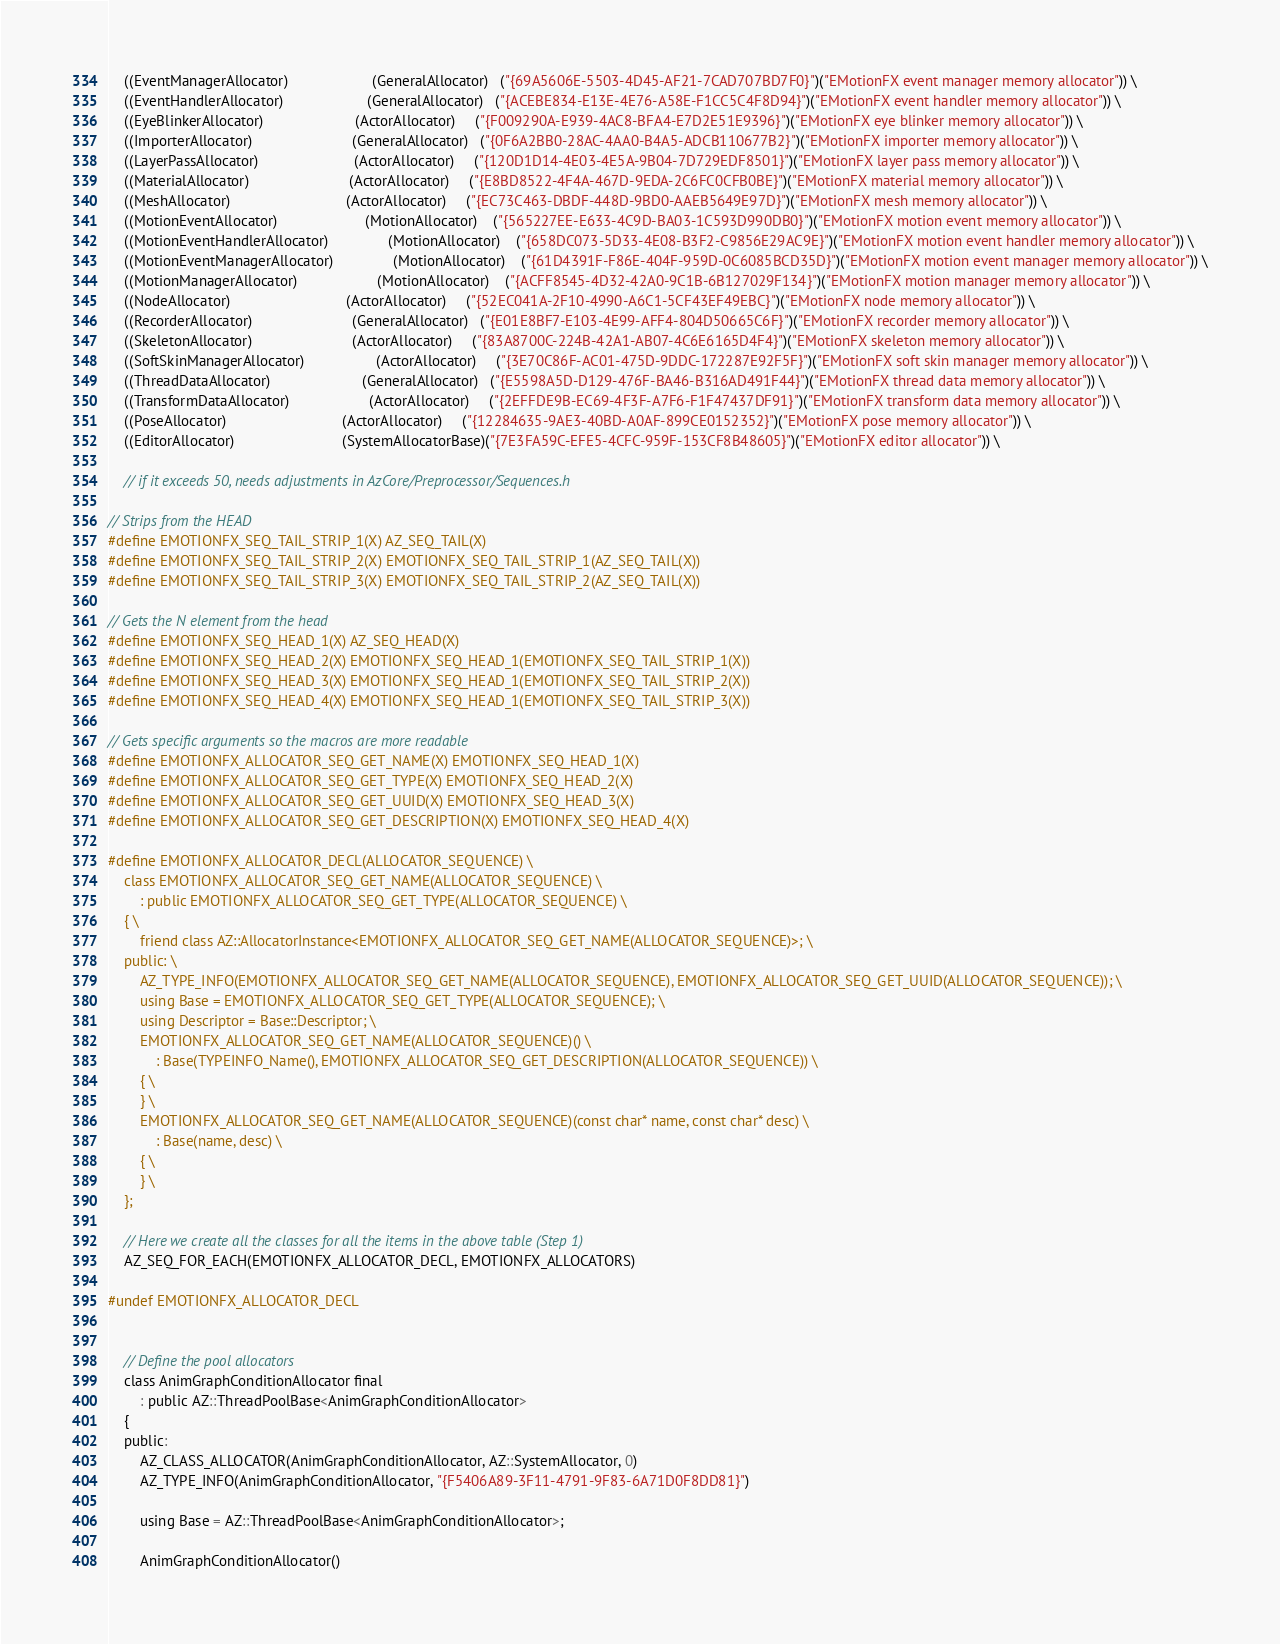Convert code to text. <code><loc_0><loc_0><loc_500><loc_500><_C_>    ((EventManagerAllocator)                     (GeneralAllocator)   ("{69A5606E-5503-4D45-AF21-7CAD707BD7F0}")("EMotionFX event manager memory allocator")) \
    ((EventHandlerAllocator)                     (GeneralAllocator)   ("{ACEBE834-E13E-4E76-A58E-F1CC5C4F8D94}")("EMotionFX event handler memory allocator")) \
    ((EyeBlinkerAllocator)                       (ActorAllocator)     ("{F009290A-E939-4AC8-BFA4-E7D2E51E9396}")("EMotionFX eye blinker memory allocator")) \
    ((ImporterAllocator)                         (GeneralAllocator)   ("{0F6A2BB0-28AC-4AA0-B4A5-ADCB110677B2}")("EMotionFX importer memory allocator")) \
    ((LayerPassAllocator)                        (ActorAllocator)     ("{120D1D14-4E03-4E5A-9B04-7D729EDF8501}")("EMotionFX layer pass memory allocator")) \
    ((MaterialAllocator)                         (ActorAllocator)     ("{E8BD8522-4F4A-467D-9EDA-2C6FC0CFB0BE}")("EMotionFX material memory allocator")) \
    ((MeshAllocator)                             (ActorAllocator)     ("{EC73C463-DBDF-448D-9BD0-AAEB5649E97D}")("EMotionFX mesh memory allocator")) \
    ((MotionEventAllocator)                      (MotionAllocator)    ("{565227EE-E633-4C9D-BA03-1C593D990DB0}")("EMotionFX motion event memory allocator")) \
    ((MotionEventHandlerAllocator)               (MotionAllocator)    ("{658DC073-5D33-4E08-B3F2-C9856E29AC9E}")("EMotionFX motion event handler memory allocator")) \
    ((MotionEventManagerAllocator)               (MotionAllocator)    ("{61D4391F-F86E-404F-959D-0C6085BCD35D}")("EMotionFX motion event manager memory allocator")) \
    ((MotionManagerAllocator)                    (MotionAllocator)    ("{ACFF8545-4D32-42A0-9C1B-6B127029F134}")("EMotionFX motion manager memory allocator")) \
    ((NodeAllocator)                             (ActorAllocator)     ("{52EC041A-2F10-4990-A6C1-5CF43EF49EBC}")("EMotionFX node memory allocator")) \
    ((RecorderAllocator)                         (GeneralAllocator)   ("{E01E8BF7-E103-4E99-AFF4-804D50665C6F}")("EMotionFX recorder memory allocator")) \
    ((SkeletonAllocator)                         (ActorAllocator)     ("{83A8700C-224B-42A1-AB07-4C6E6165D4F4}")("EMotionFX skeleton memory allocator")) \
    ((SoftSkinManagerAllocator)                  (ActorAllocator)     ("{3E70C86F-AC01-475D-9DDC-172287E92F5F}")("EMotionFX soft skin manager memory allocator")) \
    ((ThreadDataAllocator)                       (GeneralAllocator)   ("{E5598A5D-D129-476F-BA46-B316AD491F44}")("EMotionFX thread data memory allocator")) \
    ((TransformDataAllocator)                    (ActorAllocator)     ("{2EFFDE9B-EC69-4F3F-A7F6-F1F47437DF91}")("EMotionFX transform data memory allocator")) \
    ((PoseAllocator)                             (ActorAllocator)     ("{12284635-9AE3-40BD-A0AF-899CE0152352}")("EMotionFX pose memory allocator")) \
    ((EditorAllocator)                           (SystemAllocatorBase)("{7E3FA59C-EFE5-4CFC-959F-153CF8B48605}")("EMotionFX editor allocator")) \

    // if it exceeds 50, needs adjustments in AzCore/Preprocessor/Sequences.h

// Strips from the HEAD
#define EMOTIONFX_SEQ_TAIL_STRIP_1(X) AZ_SEQ_TAIL(X)
#define EMOTIONFX_SEQ_TAIL_STRIP_2(X) EMOTIONFX_SEQ_TAIL_STRIP_1(AZ_SEQ_TAIL(X))
#define EMOTIONFX_SEQ_TAIL_STRIP_3(X) EMOTIONFX_SEQ_TAIL_STRIP_2(AZ_SEQ_TAIL(X))

// Gets the N element from the head
#define EMOTIONFX_SEQ_HEAD_1(X) AZ_SEQ_HEAD(X)
#define EMOTIONFX_SEQ_HEAD_2(X) EMOTIONFX_SEQ_HEAD_1(EMOTIONFX_SEQ_TAIL_STRIP_1(X))
#define EMOTIONFX_SEQ_HEAD_3(X) EMOTIONFX_SEQ_HEAD_1(EMOTIONFX_SEQ_TAIL_STRIP_2(X))
#define EMOTIONFX_SEQ_HEAD_4(X) EMOTIONFX_SEQ_HEAD_1(EMOTIONFX_SEQ_TAIL_STRIP_3(X))

// Gets specific arguments so the macros are more readable
#define EMOTIONFX_ALLOCATOR_SEQ_GET_NAME(X) EMOTIONFX_SEQ_HEAD_1(X)
#define EMOTIONFX_ALLOCATOR_SEQ_GET_TYPE(X) EMOTIONFX_SEQ_HEAD_2(X)
#define EMOTIONFX_ALLOCATOR_SEQ_GET_UUID(X) EMOTIONFX_SEQ_HEAD_3(X)
#define EMOTIONFX_ALLOCATOR_SEQ_GET_DESCRIPTION(X) EMOTIONFX_SEQ_HEAD_4(X)

#define EMOTIONFX_ALLOCATOR_DECL(ALLOCATOR_SEQUENCE) \
    class EMOTIONFX_ALLOCATOR_SEQ_GET_NAME(ALLOCATOR_SEQUENCE) \
        : public EMOTIONFX_ALLOCATOR_SEQ_GET_TYPE(ALLOCATOR_SEQUENCE) \
    { \
        friend class AZ::AllocatorInstance<EMOTIONFX_ALLOCATOR_SEQ_GET_NAME(ALLOCATOR_SEQUENCE)>; \
    public: \
        AZ_TYPE_INFO(EMOTIONFX_ALLOCATOR_SEQ_GET_NAME(ALLOCATOR_SEQUENCE), EMOTIONFX_ALLOCATOR_SEQ_GET_UUID(ALLOCATOR_SEQUENCE)); \
        using Base = EMOTIONFX_ALLOCATOR_SEQ_GET_TYPE(ALLOCATOR_SEQUENCE); \
        using Descriptor = Base::Descriptor; \
        EMOTIONFX_ALLOCATOR_SEQ_GET_NAME(ALLOCATOR_SEQUENCE)() \
            : Base(TYPEINFO_Name(), EMOTIONFX_ALLOCATOR_SEQ_GET_DESCRIPTION(ALLOCATOR_SEQUENCE)) \
        { \
        } \
        EMOTIONFX_ALLOCATOR_SEQ_GET_NAME(ALLOCATOR_SEQUENCE)(const char* name, const char* desc) \
            : Base(name, desc) \
        { \
        } \
    };

    // Here we create all the classes for all the items in the above table (Step 1)
    AZ_SEQ_FOR_EACH(EMOTIONFX_ALLOCATOR_DECL, EMOTIONFX_ALLOCATORS)

#undef EMOTIONFX_ALLOCATOR_DECL


    // Define the pool allocators
    class AnimGraphConditionAllocator final
        : public AZ::ThreadPoolBase<AnimGraphConditionAllocator>
    {
    public:
        AZ_CLASS_ALLOCATOR(AnimGraphConditionAllocator, AZ::SystemAllocator, 0)
        AZ_TYPE_INFO(AnimGraphConditionAllocator, "{F5406A89-3F11-4791-9F83-6A71D0F8DD81}")

        using Base = AZ::ThreadPoolBase<AnimGraphConditionAllocator>;

        AnimGraphConditionAllocator()</code> 